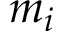Convert formula to latex. <formula><loc_0><loc_0><loc_500><loc_500>m _ { i }</formula> 